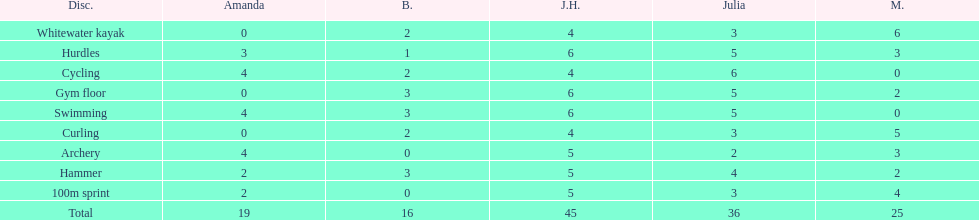Name a girl that had the same score in cycling and archery. Amanda. 